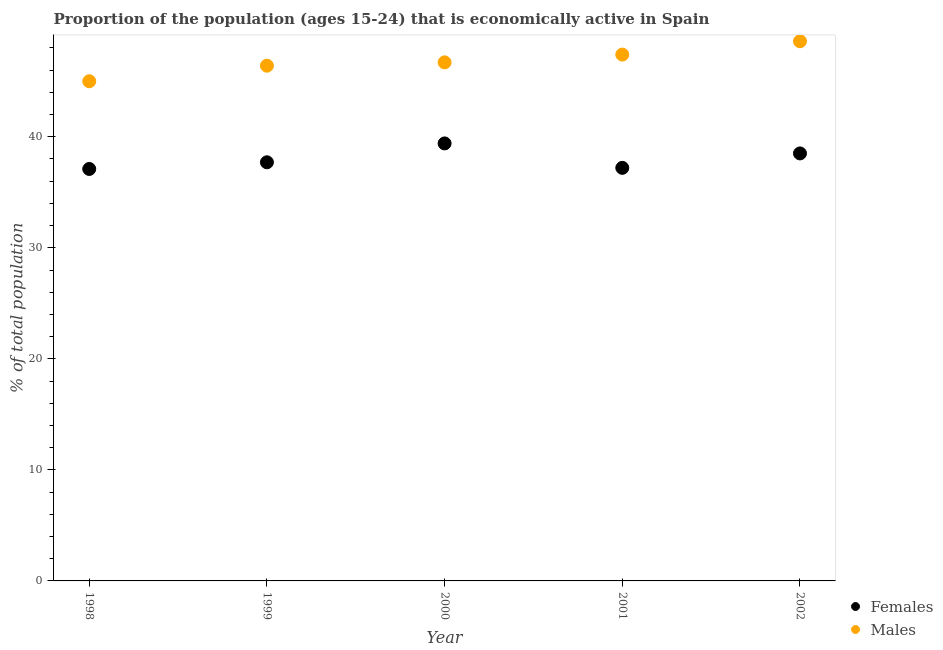What is the percentage of economically active female population in 2000?
Keep it short and to the point. 39.4. Across all years, what is the maximum percentage of economically active female population?
Offer a terse response. 39.4. Across all years, what is the minimum percentage of economically active female population?
Keep it short and to the point. 37.1. In which year was the percentage of economically active male population maximum?
Offer a very short reply. 2002. In which year was the percentage of economically active female population minimum?
Offer a very short reply. 1998. What is the total percentage of economically active male population in the graph?
Ensure brevity in your answer.  234.1. What is the difference between the percentage of economically active male population in 1998 and that in 2000?
Your answer should be very brief. -1.7. What is the difference between the percentage of economically active male population in 2001 and the percentage of economically active female population in 1999?
Make the answer very short. 9.7. What is the average percentage of economically active male population per year?
Provide a succinct answer. 46.82. In the year 2001, what is the difference between the percentage of economically active female population and percentage of economically active male population?
Provide a succinct answer. -10.2. What is the ratio of the percentage of economically active female population in 2001 to that in 2002?
Your response must be concise. 0.97. Is the percentage of economically active male population in 2001 less than that in 2002?
Give a very brief answer. Yes. What is the difference between the highest and the second highest percentage of economically active male population?
Keep it short and to the point. 1.2. What is the difference between the highest and the lowest percentage of economically active female population?
Your answer should be very brief. 2.3. Is the percentage of economically active male population strictly greater than the percentage of economically active female population over the years?
Give a very brief answer. Yes. How many years are there in the graph?
Provide a succinct answer. 5. What is the difference between two consecutive major ticks on the Y-axis?
Ensure brevity in your answer.  10. Does the graph contain grids?
Provide a succinct answer. No. How many legend labels are there?
Your answer should be compact. 2. What is the title of the graph?
Your response must be concise. Proportion of the population (ages 15-24) that is economically active in Spain. Does "Highest 10% of population" appear as one of the legend labels in the graph?
Give a very brief answer. No. What is the label or title of the Y-axis?
Make the answer very short. % of total population. What is the % of total population of Females in 1998?
Ensure brevity in your answer.  37.1. What is the % of total population in Males in 1998?
Offer a terse response. 45. What is the % of total population in Females in 1999?
Make the answer very short. 37.7. What is the % of total population of Males in 1999?
Offer a very short reply. 46.4. What is the % of total population of Females in 2000?
Your answer should be very brief. 39.4. What is the % of total population of Males in 2000?
Offer a terse response. 46.7. What is the % of total population in Females in 2001?
Provide a succinct answer. 37.2. What is the % of total population in Males in 2001?
Offer a terse response. 47.4. What is the % of total population in Females in 2002?
Your answer should be very brief. 38.5. What is the % of total population in Males in 2002?
Provide a succinct answer. 48.6. Across all years, what is the maximum % of total population in Females?
Provide a short and direct response. 39.4. Across all years, what is the maximum % of total population in Males?
Ensure brevity in your answer.  48.6. Across all years, what is the minimum % of total population in Females?
Provide a succinct answer. 37.1. Across all years, what is the minimum % of total population in Males?
Offer a very short reply. 45. What is the total % of total population in Females in the graph?
Give a very brief answer. 189.9. What is the total % of total population of Males in the graph?
Provide a short and direct response. 234.1. What is the difference between the % of total population of Females in 1998 and that in 2000?
Give a very brief answer. -2.3. What is the difference between the % of total population in Males in 1998 and that in 2000?
Give a very brief answer. -1.7. What is the difference between the % of total population in Females in 1998 and that in 2001?
Provide a short and direct response. -0.1. What is the difference between the % of total population of Males in 1998 and that in 2001?
Your answer should be compact. -2.4. What is the difference between the % of total population in Females in 1998 and that in 2002?
Keep it short and to the point. -1.4. What is the difference between the % of total population in Males in 1999 and that in 2002?
Your answer should be very brief. -2.2. What is the difference between the % of total population in Females in 2000 and that in 2002?
Keep it short and to the point. 0.9. What is the difference between the % of total population of Males in 2000 and that in 2002?
Your response must be concise. -1.9. What is the difference between the % of total population of Females in 2001 and that in 2002?
Offer a terse response. -1.3. What is the difference between the % of total population of Females in 1998 and the % of total population of Males in 1999?
Give a very brief answer. -9.3. What is the difference between the % of total population in Females in 1998 and the % of total population in Males in 2000?
Offer a very short reply. -9.6. What is the difference between the % of total population in Females in 1999 and the % of total population in Males in 2000?
Make the answer very short. -9. What is the difference between the % of total population in Females in 1999 and the % of total population in Males in 2001?
Your answer should be compact. -9.7. What is the difference between the % of total population in Females in 1999 and the % of total population in Males in 2002?
Offer a terse response. -10.9. What is the difference between the % of total population in Females in 2000 and the % of total population in Males in 2002?
Offer a very short reply. -9.2. What is the average % of total population of Females per year?
Your answer should be very brief. 37.98. What is the average % of total population of Males per year?
Make the answer very short. 46.82. In the year 1999, what is the difference between the % of total population in Females and % of total population in Males?
Keep it short and to the point. -8.7. In the year 2000, what is the difference between the % of total population in Females and % of total population in Males?
Provide a succinct answer. -7.3. What is the ratio of the % of total population of Females in 1998 to that in 1999?
Make the answer very short. 0.98. What is the ratio of the % of total population in Males in 1998 to that in 1999?
Make the answer very short. 0.97. What is the ratio of the % of total population of Females in 1998 to that in 2000?
Your response must be concise. 0.94. What is the ratio of the % of total population in Males in 1998 to that in 2000?
Offer a terse response. 0.96. What is the ratio of the % of total population in Males in 1998 to that in 2001?
Your answer should be compact. 0.95. What is the ratio of the % of total population in Females in 1998 to that in 2002?
Ensure brevity in your answer.  0.96. What is the ratio of the % of total population in Males in 1998 to that in 2002?
Make the answer very short. 0.93. What is the ratio of the % of total population in Females in 1999 to that in 2000?
Provide a short and direct response. 0.96. What is the ratio of the % of total population in Females in 1999 to that in 2001?
Your answer should be compact. 1.01. What is the ratio of the % of total population of Males in 1999 to that in 2001?
Give a very brief answer. 0.98. What is the ratio of the % of total population in Females in 1999 to that in 2002?
Ensure brevity in your answer.  0.98. What is the ratio of the % of total population in Males in 1999 to that in 2002?
Offer a terse response. 0.95. What is the ratio of the % of total population of Females in 2000 to that in 2001?
Your response must be concise. 1.06. What is the ratio of the % of total population of Males in 2000 to that in 2001?
Make the answer very short. 0.99. What is the ratio of the % of total population of Females in 2000 to that in 2002?
Your response must be concise. 1.02. What is the ratio of the % of total population of Males in 2000 to that in 2002?
Provide a short and direct response. 0.96. What is the ratio of the % of total population of Females in 2001 to that in 2002?
Keep it short and to the point. 0.97. What is the ratio of the % of total population in Males in 2001 to that in 2002?
Give a very brief answer. 0.98. What is the difference between the highest and the lowest % of total population of Females?
Your answer should be very brief. 2.3. 